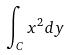Convert formula to latex. <formula><loc_0><loc_0><loc_500><loc_500>\int _ { C } x ^ { 2 } d y</formula> 